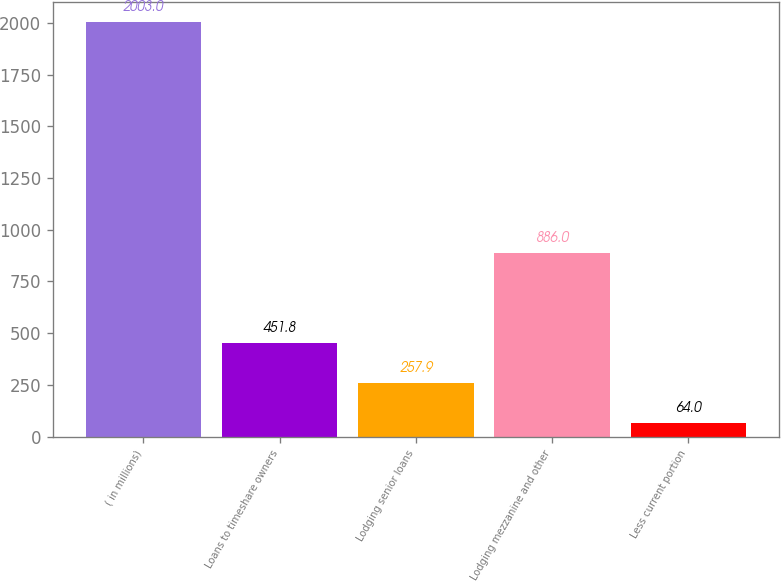Convert chart to OTSL. <chart><loc_0><loc_0><loc_500><loc_500><bar_chart><fcel>( in millions)<fcel>Loans to timeshare owners<fcel>Lodging senior loans<fcel>Lodging mezzanine and other<fcel>Less current portion<nl><fcel>2003<fcel>451.8<fcel>257.9<fcel>886<fcel>64<nl></chart> 